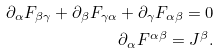<formula> <loc_0><loc_0><loc_500><loc_500>\partial _ { \alpha } F _ { \beta \gamma } + \partial _ { \beta } F _ { \gamma \alpha } + \partial _ { \gamma } F _ { \alpha \beta } = 0 \\ \partial _ { \alpha } F ^ { \alpha \beta } = J ^ { \beta } .</formula> 